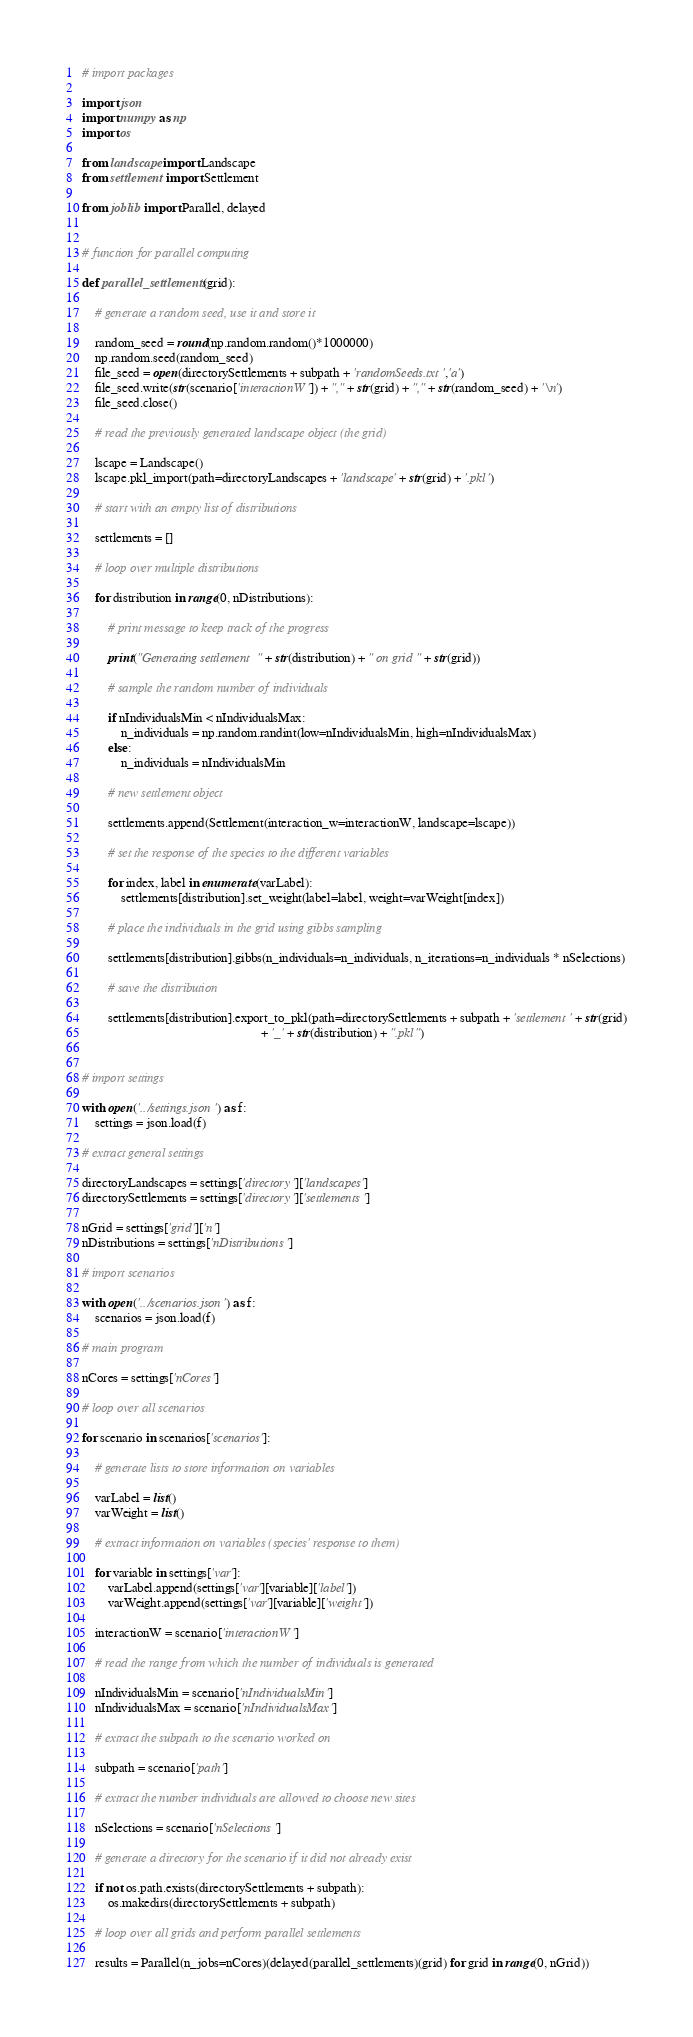Convert code to text. <code><loc_0><loc_0><loc_500><loc_500><_Python_>
# import packages

import json
import numpy as np
import os

from landscape import Landscape
from settlement import Settlement

from joblib import Parallel, delayed


# function for parallel computing

def parallel_settlements(grid):
    
    # generate a random seed, use it and store it
    
    random_seed = round(np.random.random()*1000000)
    np.random.seed(random_seed)
    file_seed = open(directorySettlements + subpath + 'randomSeeds.txt','a')
    file_seed.write(str(scenario['interactionW']) + "," + str(grid) + "," + str(random_seed) + '\n')
    file_seed.close()
    
    # read the previously generated landscape object (the grid)
    
    lscape = Landscape()
    lscape.pkl_import(path=directoryLandscapes + 'landscape' + str(grid) + '.pkl')
        
    # start with an empty list of distributions
    
    settlements = []
    
    # loop over multiple distributions
    
    for distribution in range(0, nDistributions):
    
        # print message to keep track of the progress
                       
        print("Generating settlement " + str(distribution) + " on grid " + str(grid))
    
        # sample the random number of individuals

        if nIndividualsMin < nIndividualsMax:
            n_individuals = np.random.randint(low=nIndividualsMin, high=nIndividualsMax)
        else:
            n_individuals = nIndividualsMin

        # new settlement object

        settlements.append(Settlement(interaction_w=interactionW, landscape=lscape))
        
        # set the response of the species to the different variables
        
        for index, label in enumerate(varLabel):
            settlements[distribution].set_weight(label=label, weight=varWeight[index])
               
        # place the individuals in the grid using gibbs sampling
        
        settlements[distribution].gibbs(n_individuals=n_individuals, n_iterations=n_individuals * nSelections)

        # save the distribution

        settlements[distribution].export_to_pkl(path=directorySettlements + subpath + 'settlement' + str(grid)
                                                       + '_' + str(distribution) + ".pkl")


# import settings

with open('../settings.json') as f:
    settings = json.load(f)

# extract general settings

directoryLandscapes = settings['directory']['landscapes']
directorySettlements = settings['directory']['settlements']

nGrid = settings['grid']['n']
nDistributions = settings['nDistributions']

# import scenarios

with open('../scenarios.json') as f:
    scenarios = json.load(f)

# main program

nCores = settings['nCores']

# loop over all scenarios

for scenario in scenarios['scenarios']:

    # generate lists to store information on variables
       
    varLabel = list()
    varWeight = list()
    
    # extract information on variables (species' response to them)
    
    for variable in settings['var']:
        varLabel.append(settings['var'][variable]['label'])
        varWeight.append(settings['var'][variable]['weight'])

    interactionW = scenario['interactionW']
    
    # read the range from which the number of individuals is generated
    
    nIndividualsMin = scenario['nIndividualsMin']
    nIndividualsMax = scenario['nIndividualsMax']
        
    # extract the subpath to the scenario worked on

    subpath = scenario['path']

    # extract the number individuals are allowed to choose new sites

    nSelections = scenario['nSelections']
    
    # generate a directory for the scenario if it did not already exist
    
    if not os.path.exists(directorySettlements + subpath):
        os.makedirs(directorySettlements + subpath)
            
    # loop over all grids and perform parallel settlements
    
    results = Parallel(n_jobs=nCores)(delayed(parallel_settlements)(grid) for grid in range(0, nGrid))
</code> 